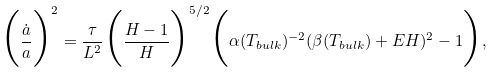Convert formula to latex. <formula><loc_0><loc_0><loc_500><loc_500>\Big { ( } \frac { \dot { a } } { a } \Big { ) } ^ { 2 } = \frac { \tau } { L ^ { 2 } } \Big { ( } \frac { H - 1 } { H } \Big { ) } ^ { 5 / 2 } \Big { ( } \alpha ( T _ { b u l k } ) ^ { - 2 } ( \beta ( T _ { b u l k } ) + E H ) ^ { 2 } - 1 \Big { ) } ,</formula> 